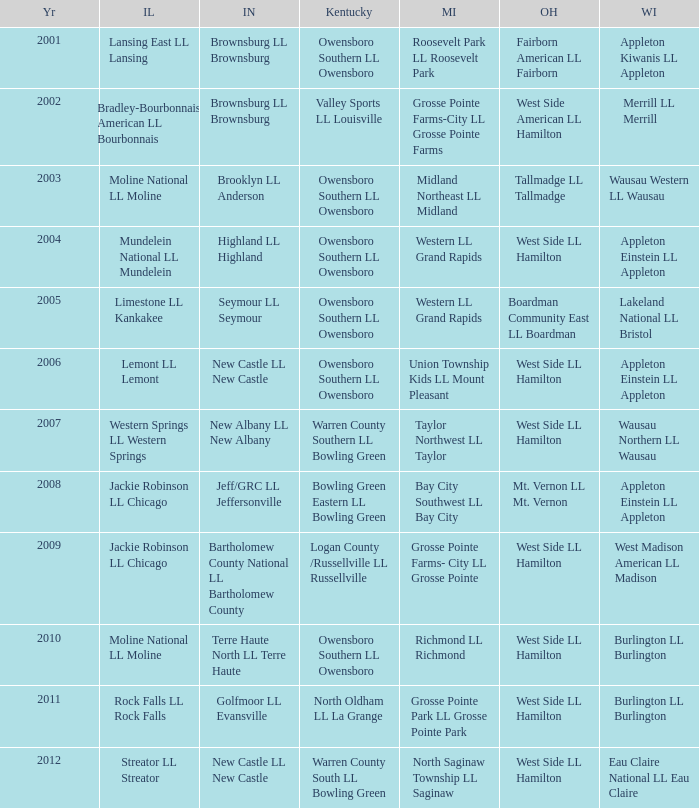What was the little league team from Kentucky when the little league team from Illinois was Rock Falls LL Rock Falls? North Oldham LL La Grange. 